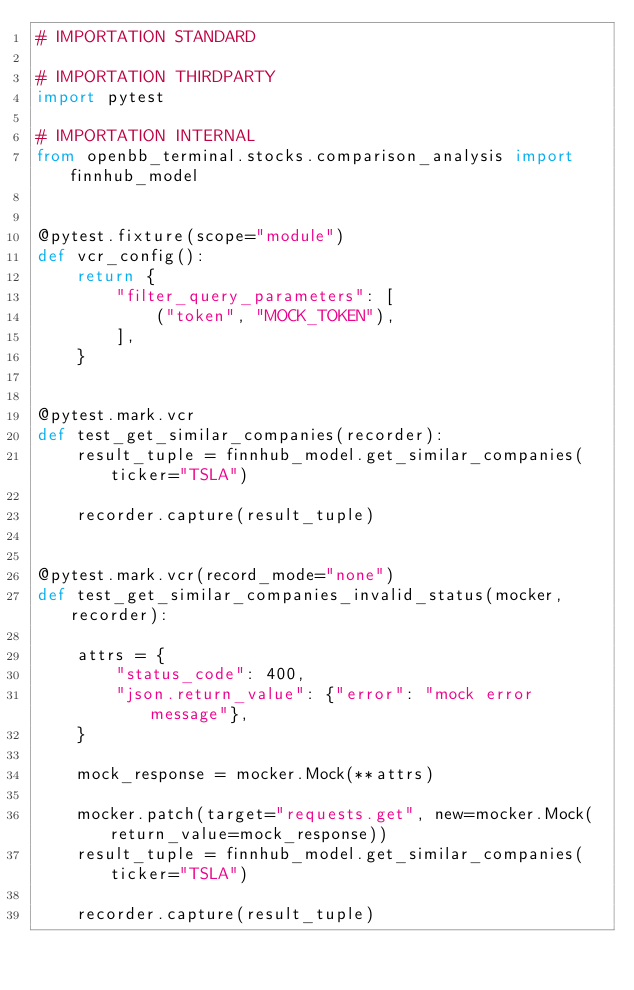<code> <loc_0><loc_0><loc_500><loc_500><_Python_># IMPORTATION STANDARD

# IMPORTATION THIRDPARTY
import pytest

# IMPORTATION INTERNAL
from openbb_terminal.stocks.comparison_analysis import finnhub_model


@pytest.fixture(scope="module")
def vcr_config():
    return {
        "filter_query_parameters": [
            ("token", "MOCK_TOKEN"),
        ],
    }


@pytest.mark.vcr
def test_get_similar_companies(recorder):
    result_tuple = finnhub_model.get_similar_companies(ticker="TSLA")

    recorder.capture(result_tuple)


@pytest.mark.vcr(record_mode="none")
def test_get_similar_companies_invalid_status(mocker, recorder):

    attrs = {
        "status_code": 400,
        "json.return_value": {"error": "mock error message"},
    }

    mock_response = mocker.Mock(**attrs)

    mocker.patch(target="requests.get", new=mocker.Mock(return_value=mock_response))
    result_tuple = finnhub_model.get_similar_companies(ticker="TSLA")

    recorder.capture(result_tuple)
</code> 